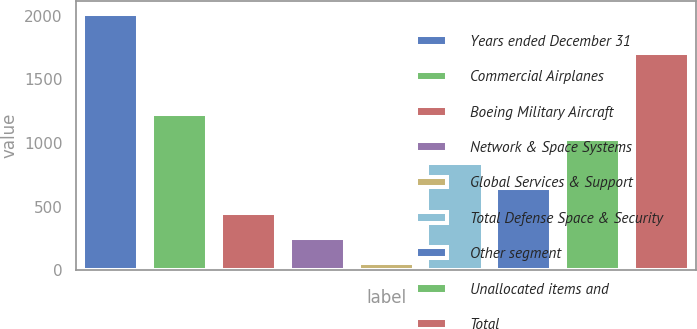<chart> <loc_0><loc_0><loc_500><loc_500><bar_chart><fcel>Years ended December 31<fcel>Commercial Airplanes<fcel>Boeing Military Aircraft<fcel>Network & Space Systems<fcel>Global Services & Support<fcel>Total Defense Space & Security<fcel>Other segment<fcel>Unallocated items and<fcel>Total<nl><fcel>2012<fcel>1230<fcel>448<fcel>252.5<fcel>57<fcel>839<fcel>643.5<fcel>1034.5<fcel>1703<nl></chart> 